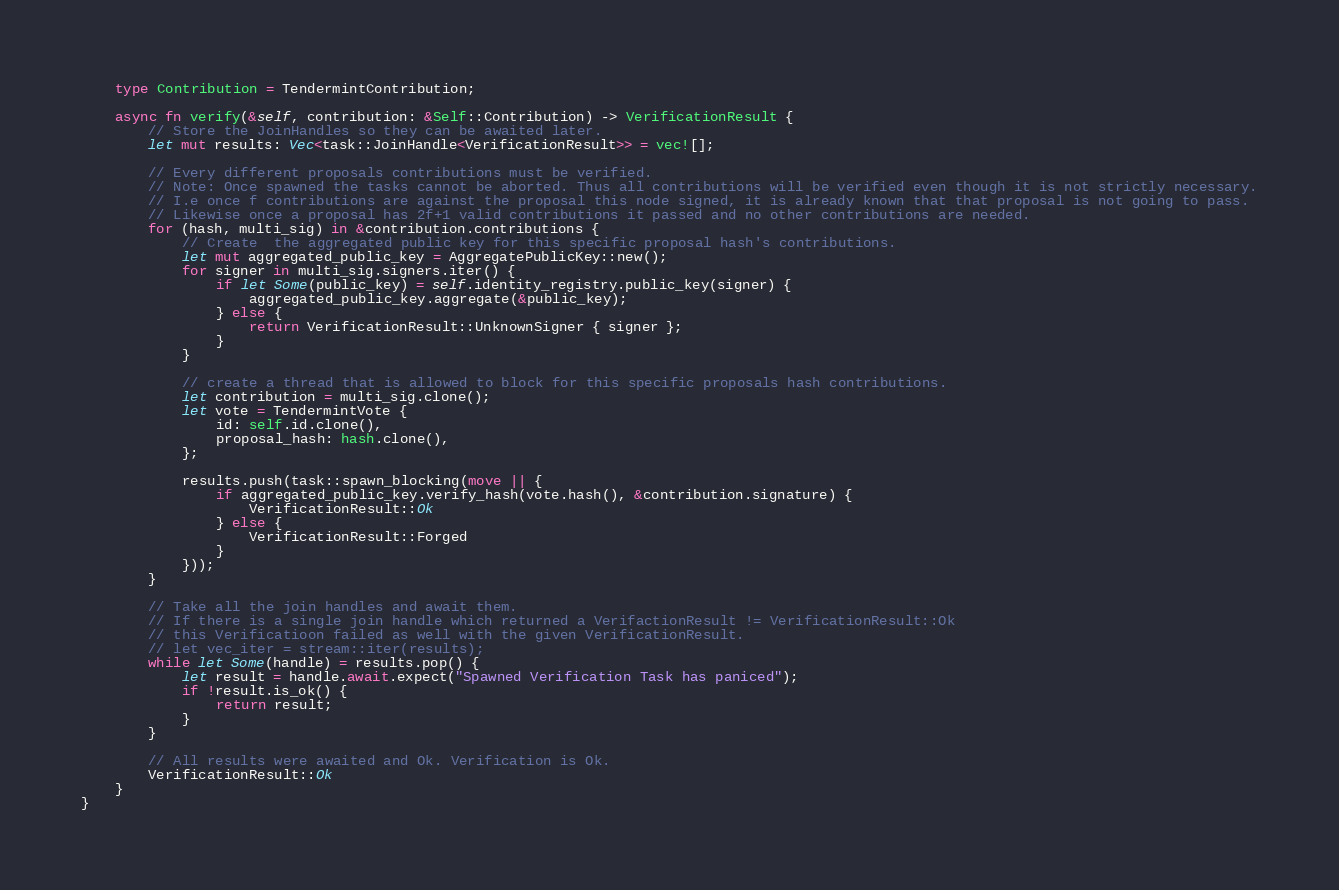<code> <loc_0><loc_0><loc_500><loc_500><_Rust_>    type Contribution = TendermintContribution;

    async fn verify(&self, contribution: &Self::Contribution) -> VerificationResult {
        // Store the JoinHandles so they can be awaited later.
        let mut results: Vec<task::JoinHandle<VerificationResult>> = vec![];

        // Every different proposals contributions must be verified.
        // Note: Once spawned the tasks cannot be aborted. Thus all contributions will be verified even though it is not strictly necessary.
        // I.e once f contributions are against the proposal this node signed, it is already known that that proposal is not going to pass.
        // Likewise once a proposal has 2f+1 valid contributions it passed and no other contributions are needed.
        for (hash, multi_sig) in &contribution.contributions {
            // Create  the aggregated public key for this specific proposal hash's contributions.
            let mut aggregated_public_key = AggregatePublicKey::new();
            for signer in multi_sig.signers.iter() {
                if let Some(public_key) = self.identity_registry.public_key(signer) {
                    aggregated_public_key.aggregate(&public_key);
                } else {
                    return VerificationResult::UnknownSigner { signer };
                }
            }

            // create a thread that is allowed to block for this specific proposals hash contributions.
            let contribution = multi_sig.clone();
            let vote = TendermintVote {
                id: self.id.clone(),
                proposal_hash: hash.clone(),
            };

            results.push(task::spawn_blocking(move || {
                if aggregated_public_key.verify_hash(vote.hash(), &contribution.signature) {
                    VerificationResult::Ok
                } else {
                    VerificationResult::Forged
                }
            }));
        }

        // Take all the join handles and await them.
        // If there is a single join handle which returned a VerifactionResult != VerificationResult::Ok
        // this Verificatioon failed as well with the given VerificationResult.
        // let vec_iter = stream::iter(results);
        while let Some(handle) = results.pop() {
            let result = handle.await.expect("Spawned Verification Task has paniced");
            if !result.is_ok() {
                return result;
            }
        }

        // All results were awaited and Ok. Verification is Ok.
        VerificationResult::Ok
    }
}
</code> 